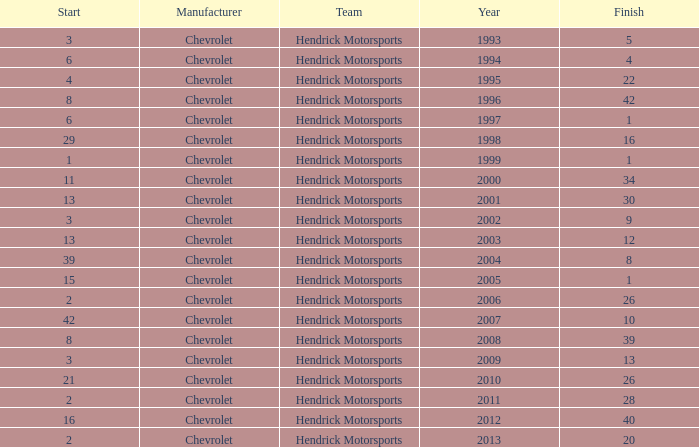What was Jeff's finish in 2011? 28.0. 